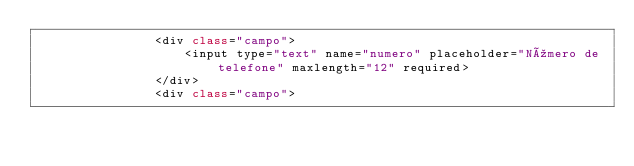<code> <loc_0><loc_0><loc_500><loc_500><_C#_>                <div class="campo">
                    <input type="text" name="numero" placeholder="Número de telefone" maxlength="12" required>
                </div>
                <div class="campo"></code> 